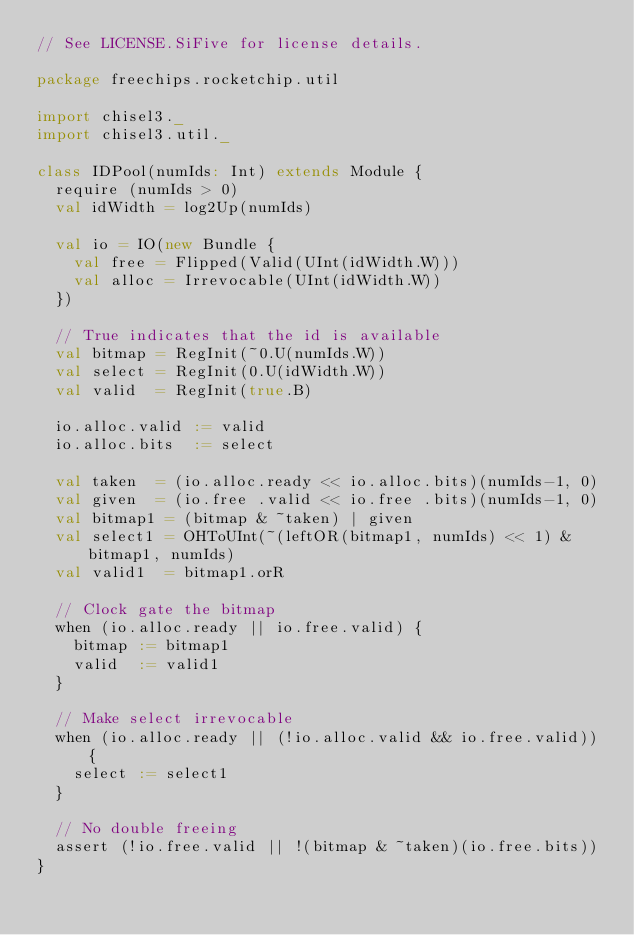Convert code to text. <code><loc_0><loc_0><loc_500><loc_500><_Scala_>// See LICENSE.SiFive for license details.

package freechips.rocketchip.util

import chisel3._
import chisel3.util._

class IDPool(numIds: Int) extends Module {
  require (numIds > 0)
  val idWidth = log2Up(numIds)

  val io = IO(new Bundle {
    val free = Flipped(Valid(UInt(idWidth.W)))
    val alloc = Irrevocable(UInt(idWidth.W))
  })

  // True indicates that the id is available
  val bitmap = RegInit(~0.U(numIds.W))
  val select = RegInit(0.U(idWidth.W))
  val valid  = RegInit(true.B)

  io.alloc.valid := valid
  io.alloc.bits  := select

  val taken  = (io.alloc.ready << io.alloc.bits)(numIds-1, 0)
  val given  = (io.free .valid << io.free .bits)(numIds-1, 0)
  val bitmap1 = (bitmap & ~taken) | given
  val select1 = OHToUInt(~(leftOR(bitmap1, numIds) << 1) & bitmap1, numIds)
  val valid1  = bitmap1.orR

  // Clock gate the bitmap
  when (io.alloc.ready || io.free.valid) {
    bitmap := bitmap1
    valid  := valid1
  }

  // Make select irrevocable
  when (io.alloc.ready || (!io.alloc.valid && io.free.valid)) {
    select := select1
  }

  // No double freeing
  assert (!io.free.valid || !(bitmap & ~taken)(io.free.bits))
}
</code> 